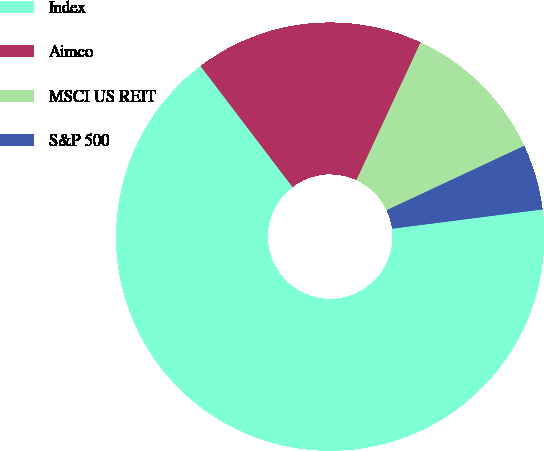<chart> <loc_0><loc_0><loc_500><loc_500><pie_chart><fcel>Index<fcel>Aimco<fcel>MSCI US REIT<fcel>S&P 500<nl><fcel>66.69%<fcel>17.28%<fcel>11.1%<fcel>4.93%<nl></chart> 